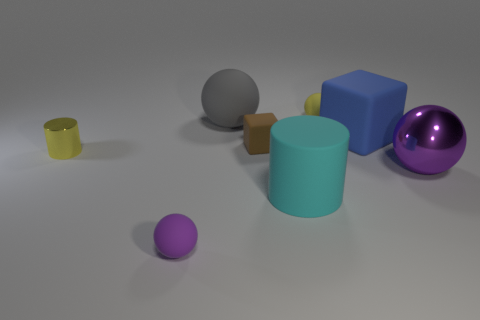Subtract all big matte spheres. How many spheres are left? 3 Subtract all cyan cylinders. How many purple spheres are left? 2 Add 1 small green shiny cylinders. How many objects exist? 9 Subtract 2 balls. How many balls are left? 2 Subtract all yellow cylinders. How many cylinders are left? 1 Subtract all cylinders. How many objects are left? 6 Subtract all blue spheres. Subtract all cyan blocks. How many spheres are left? 4 Subtract all large purple shiny balls. Subtract all purple shiny balls. How many objects are left? 6 Add 7 small cubes. How many small cubes are left? 8 Add 3 big shiny balls. How many big shiny balls exist? 4 